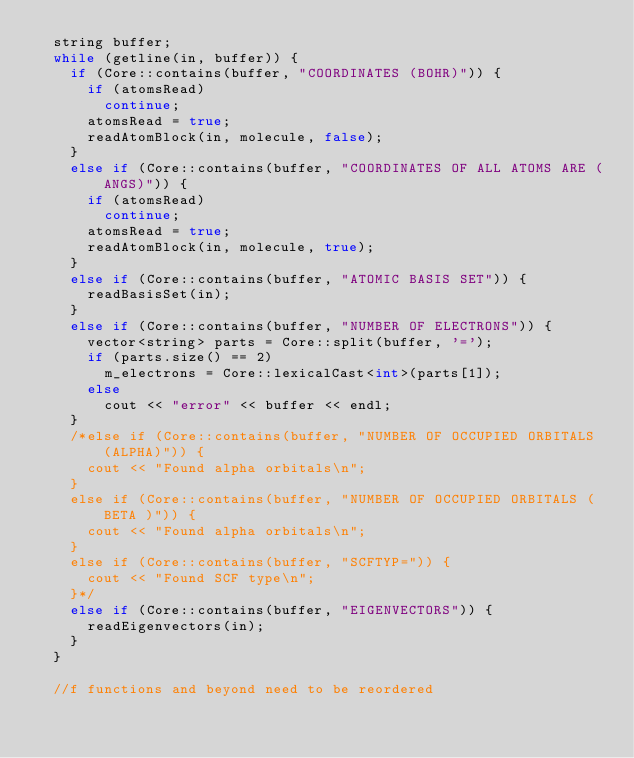<code> <loc_0><loc_0><loc_500><loc_500><_C++_>  string buffer;
  while (getline(in, buffer)) {
    if (Core::contains(buffer, "COORDINATES (BOHR)")) {
      if (atomsRead)
        continue;
      atomsRead = true;
      readAtomBlock(in, molecule, false);
    }
    else if (Core::contains(buffer, "COORDINATES OF ALL ATOMS ARE (ANGS)")) {
      if (atomsRead)
        continue;
      atomsRead = true;
      readAtomBlock(in, molecule, true);
    }
    else if (Core::contains(buffer, "ATOMIC BASIS SET")) {
      readBasisSet(in);
    }
    else if (Core::contains(buffer, "NUMBER OF ELECTRONS")) {
      vector<string> parts = Core::split(buffer, '=');
      if (parts.size() == 2)
        m_electrons = Core::lexicalCast<int>(parts[1]);
      else
        cout << "error" << buffer << endl;
    }
    /*else if (Core::contains(buffer, "NUMBER OF OCCUPIED ORBITALS (ALPHA)")) {
      cout << "Found alpha orbitals\n";
    }
    else if (Core::contains(buffer, "NUMBER OF OCCUPIED ORBITALS (BETA )")) {
      cout << "Found alpha orbitals\n";
    }
    else if (Core::contains(buffer, "SCFTYP=")) {
      cout << "Found SCF type\n";
    }*/
    else if (Core::contains(buffer, "EIGENVECTORS")) {
      readEigenvectors(in);
    }
  }

  //f functions and beyond need to be reordered</code> 